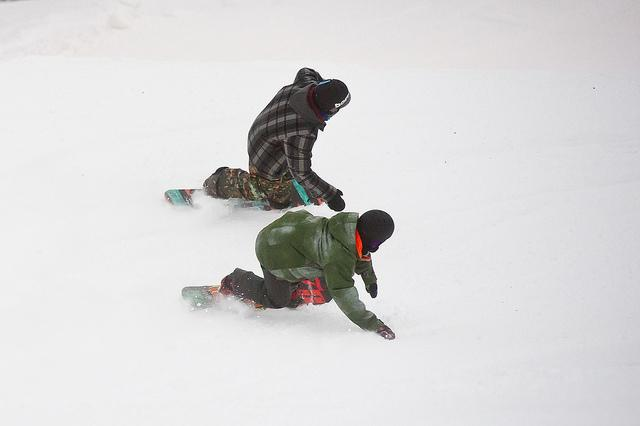What is the person on the right's hand touching? Please explain your reasoning. snow. The person on the right has their hand near the snow. 